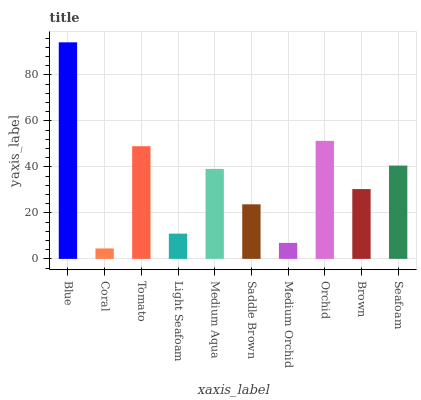Is Tomato the minimum?
Answer yes or no. No. Is Tomato the maximum?
Answer yes or no. No. Is Tomato greater than Coral?
Answer yes or no. Yes. Is Coral less than Tomato?
Answer yes or no. Yes. Is Coral greater than Tomato?
Answer yes or no. No. Is Tomato less than Coral?
Answer yes or no. No. Is Medium Aqua the high median?
Answer yes or no. Yes. Is Brown the low median?
Answer yes or no. Yes. Is Light Seafoam the high median?
Answer yes or no. No. Is Light Seafoam the low median?
Answer yes or no. No. 